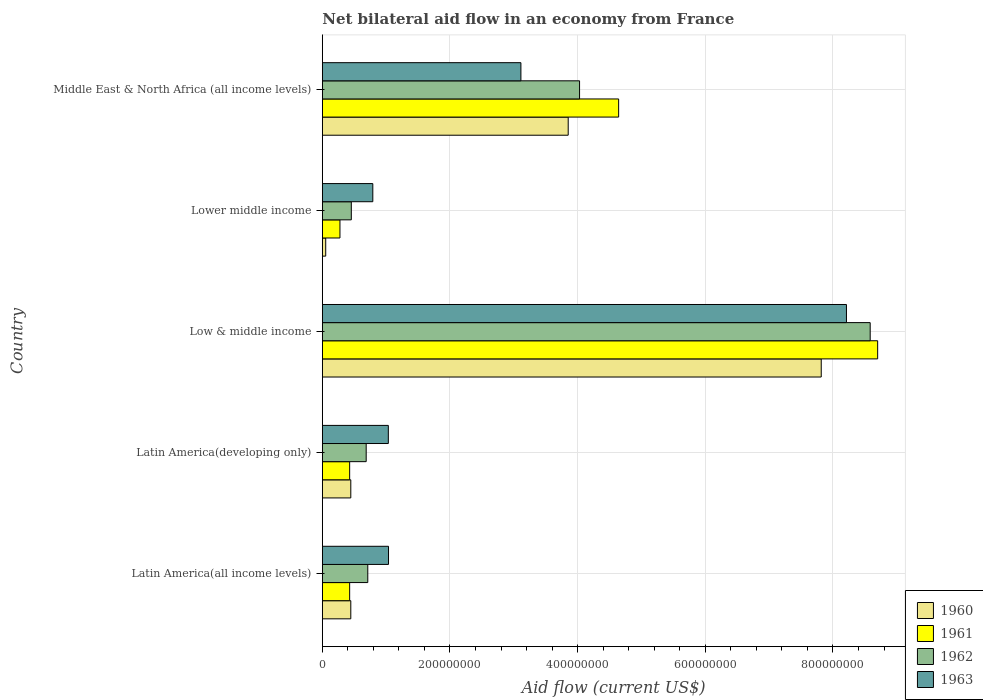How many different coloured bars are there?
Keep it short and to the point. 4. How many bars are there on the 4th tick from the bottom?
Provide a short and direct response. 4. What is the label of the 5th group of bars from the top?
Provide a succinct answer. Latin America(all income levels). What is the net bilateral aid flow in 1960 in Latin America(all income levels)?
Your response must be concise. 4.46e+07. Across all countries, what is the maximum net bilateral aid flow in 1963?
Ensure brevity in your answer.  8.21e+08. Across all countries, what is the minimum net bilateral aid flow in 1963?
Ensure brevity in your answer.  7.91e+07. In which country was the net bilateral aid flow in 1961 minimum?
Make the answer very short. Lower middle income. What is the total net bilateral aid flow in 1961 in the graph?
Ensure brevity in your answer.  1.45e+09. What is the difference between the net bilateral aid flow in 1962 in Low & middle income and that in Lower middle income?
Offer a terse response. 8.13e+08. What is the difference between the net bilateral aid flow in 1961 in Latin America(developing only) and the net bilateral aid flow in 1960 in Low & middle income?
Offer a terse response. -7.39e+08. What is the average net bilateral aid flow in 1963 per country?
Offer a very short reply. 2.84e+08. What is the difference between the net bilateral aid flow in 1960 and net bilateral aid flow in 1962 in Middle East & North Africa (all income levels)?
Provide a short and direct response. -1.78e+07. What is the ratio of the net bilateral aid flow in 1960 in Lower middle income to that in Middle East & North Africa (all income levels)?
Give a very brief answer. 0.01. Is the difference between the net bilateral aid flow in 1960 in Latin America(all income levels) and Low & middle income greater than the difference between the net bilateral aid flow in 1962 in Latin America(all income levels) and Low & middle income?
Provide a succinct answer. Yes. What is the difference between the highest and the second highest net bilateral aid flow in 1961?
Ensure brevity in your answer.  4.06e+08. What is the difference between the highest and the lowest net bilateral aid flow in 1961?
Make the answer very short. 8.42e+08. Is the sum of the net bilateral aid flow in 1963 in Latin America(all income levels) and Low & middle income greater than the maximum net bilateral aid flow in 1961 across all countries?
Provide a short and direct response. Yes. Is it the case that in every country, the sum of the net bilateral aid flow in 1961 and net bilateral aid flow in 1963 is greater than the sum of net bilateral aid flow in 1962 and net bilateral aid flow in 1960?
Ensure brevity in your answer.  No. What does the 1st bar from the top in Latin America(all income levels) represents?
Your response must be concise. 1963. Is it the case that in every country, the sum of the net bilateral aid flow in 1962 and net bilateral aid flow in 1961 is greater than the net bilateral aid flow in 1960?
Provide a short and direct response. Yes. How many countries are there in the graph?
Your answer should be very brief. 5. How many legend labels are there?
Ensure brevity in your answer.  4. How are the legend labels stacked?
Your answer should be compact. Vertical. What is the title of the graph?
Keep it short and to the point. Net bilateral aid flow in an economy from France. What is the label or title of the X-axis?
Your answer should be compact. Aid flow (current US$). What is the label or title of the Y-axis?
Provide a succinct answer. Country. What is the Aid flow (current US$) in 1960 in Latin America(all income levels)?
Offer a very short reply. 4.46e+07. What is the Aid flow (current US$) of 1961 in Latin America(all income levels)?
Give a very brief answer. 4.28e+07. What is the Aid flow (current US$) in 1962 in Latin America(all income levels)?
Make the answer very short. 7.12e+07. What is the Aid flow (current US$) of 1963 in Latin America(all income levels)?
Offer a terse response. 1.04e+08. What is the Aid flow (current US$) in 1960 in Latin America(developing only)?
Ensure brevity in your answer.  4.46e+07. What is the Aid flow (current US$) of 1961 in Latin America(developing only)?
Your answer should be compact. 4.28e+07. What is the Aid flow (current US$) of 1962 in Latin America(developing only)?
Provide a succinct answer. 6.87e+07. What is the Aid flow (current US$) of 1963 in Latin America(developing only)?
Provide a succinct answer. 1.03e+08. What is the Aid flow (current US$) of 1960 in Low & middle income?
Offer a very short reply. 7.82e+08. What is the Aid flow (current US$) of 1961 in Low & middle income?
Your answer should be very brief. 8.70e+08. What is the Aid flow (current US$) of 1962 in Low & middle income?
Offer a very short reply. 8.58e+08. What is the Aid flow (current US$) of 1963 in Low & middle income?
Keep it short and to the point. 8.21e+08. What is the Aid flow (current US$) in 1960 in Lower middle income?
Provide a succinct answer. 5.30e+06. What is the Aid flow (current US$) of 1961 in Lower middle income?
Keep it short and to the point. 2.76e+07. What is the Aid flow (current US$) in 1962 in Lower middle income?
Make the answer very short. 4.54e+07. What is the Aid flow (current US$) of 1963 in Lower middle income?
Provide a succinct answer. 7.91e+07. What is the Aid flow (current US$) of 1960 in Middle East & North Africa (all income levels)?
Provide a succinct answer. 3.85e+08. What is the Aid flow (current US$) of 1961 in Middle East & North Africa (all income levels)?
Keep it short and to the point. 4.64e+08. What is the Aid flow (current US$) in 1962 in Middle East & North Africa (all income levels)?
Give a very brief answer. 4.03e+08. What is the Aid flow (current US$) in 1963 in Middle East & North Africa (all income levels)?
Your answer should be compact. 3.11e+08. Across all countries, what is the maximum Aid flow (current US$) of 1960?
Provide a succinct answer. 7.82e+08. Across all countries, what is the maximum Aid flow (current US$) of 1961?
Provide a succinct answer. 8.70e+08. Across all countries, what is the maximum Aid flow (current US$) in 1962?
Your answer should be compact. 8.58e+08. Across all countries, what is the maximum Aid flow (current US$) of 1963?
Keep it short and to the point. 8.21e+08. Across all countries, what is the minimum Aid flow (current US$) of 1960?
Ensure brevity in your answer.  5.30e+06. Across all countries, what is the minimum Aid flow (current US$) of 1961?
Provide a short and direct response. 2.76e+07. Across all countries, what is the minimum Aid flow (current US$) of 1962?
Your answer should be very brief. 4.54e+07. Across all countries, what is the minimum Aid flow (current US$) in 1963?
Give a very brief answer. 7.91e+07. What is the total Aid flow (current US$) of 1960 in the graph?
Give a very brief answer. 1.26e+09. What is the total Aid flow (current US$) of 1961 in the graph?
Offer a very short reply. 1.45e+09. What is the total Aid flow (current US$) in 1962 in the graph?
Provide a short and direct response. 1.45e+09. What is the total Aid flow (current US$) in 1963 in the graph?
Keep it short and to the point. 1.42e+09. What is the difference between the Aid flow (current US$) of 1962 in Latin America(all income levels) and that in Latin America(developing only)?
Your answer should be very brief. 2.50e+06. What is the difference between the Aid flow (current US$) of 1963 in Latin America(all income levels) and that in Latin America(developing only)?
Your response must be concise. 3.00e+05. What is the difference between the Aid flow (current US$) in 1960 in Latin America(all income levels) and that in Low & middle income?
Make the answer very short. -7.37e+08. What is the difference between the Aid flow (current US$) of 1961 in Latin America(all income levels) and that in Low & middle income?
Provide a short and direct response. -8.27e+08. What is the difference between the Aid flow (current US$) in 1962 in Latin America(all income levels) and that in Low & middle income?
Your answer should be compact. -7.87e+08. What is the difference between the Aid flow (current US$) of 1963 in Latin America(all income levels) and that in Low & middle income?
Keep it short and to the point. -7.17e+08. What is the difference between the Aid flow (current US$) of 1960 in Latin America(all income levels) and that in Lower middle income?
Your answer should be compact. 3.93e+07. What is the difference between the Aid flow (current US$) in 1961 in Latin America(all income levels) and that in Lower middle income?
Offer a very short reply. 1.52e+07. What is the difference between the Aid flow (current US$) in 1962 in Latin America(all income levels) and that in Lower middle income?
Your answer should be compact. 2.58e+07. What is the difference between the Aid flow (current US$) of 1963 in Latin America(all income levels) and that in Lower middle income?
Give a very brief answer. 2.46e+07. What is the difference between the Aid flow (current US$) of 1960 in Latin America(all income levels) and that in Middle East & North Africa (all income levels)?
Your answer should be compact. -3.41e+08. What is the difference between the Aid flow (current US$) of 1961 in Latin America(all income levels) and that in Middle East & North Africa (all income levels)?
Give a very brief answer. -4.21e+08. What is the difference between the Aid flow (current US$) in 1962 in Latin America(all income levels) and that in Middle East & North Africa (all income levels)?
Offer a very short reply. -3.32e+08. What is the difference between the Aid flow (current US$) in 1963 in Latin America(all income levels) and that in Middle East & North Africa (all income levels)?
Your response must be concise. -2.07e+08. What is the difference between the Aid flow (current US$) of 1960 in Latin America(developing only) and that in Low & middle income?
Ensure brevity in your answer.  -7.37e+08. What is the difference between the Aid flow (current US$) in 1961 in Latin America(developing only) and that in Low & middle income?
Provide a short and direct response. -8.27e+08. What is the difference between the Aid flow (current US$) in 1962 in Latin America(developing only) and that in Low & middle income?
Ensure brevity in your answer.  -7.90e+08. What is the difference between the Aid flow (current US$) in 1963 in Latin America(developing only) and that in Low & middle income?
Offer a very short reply. -7.18e+08. What is the difference between the Aid flow (current US$) of 1960 in Latin America(developing only) and that in Lower middle income?
Provide a succinct answer. 3.93e+07. What is the difference between the Aid flow (current US$) in 1961 in Latin America(developing only) and that in Lower middle income?
Give a very brief answer. 1.52e+07. What is the difference between the Aid flow (current US$) in 1962 in Latin America(developing only) and that in Lower middle income?
Your answer should be compact. 2.33e+07. What is the difference between the Aid flow (current US$) in 1963 in Latin America(developing only) and that in Lower middle income?
Ensure brevity in your answer.  2.43e+07. What is the difference between the Aid flow (current US$) of 1960 in Latin America(developing only) and that in Middle East & North Africa (all income levels)?
Give a very brief answer. -3.41e+08. What is the difference between the Aid flow (current US$) in 1961 in Latin America(developing only) and that in Middle East & North Africa (all income levels)?
Your response must be concise. -4.21e+08. What is the difference between the Aid flow (current US$) of 1962 in Latin America(developing only) and that in Middle East & North Africa (all income levels)?
Offer a very short reply. -3.34e+08. What is the difference between the Aid flow (current US$) in 1963 in Latin America(developing only) and that in Middle East & North Africa (all income levels)?
Keep it short and to the point. -2.08e+08. What is the difference between the Aid flow (current US$) of 1960 in Low & middle income and that in Lower middle income?
Your answer should be very brief. 7.76e+08. What is the difference between the Aid flow (current US$) in 1961 in Low & middle income and that in Lower middle income?
Keep it short and to the point. 8.42e+08. What is the difference between the Aid flow (current US$) of 1962 in Low & middle income and that in Lower middle income?
Provide a short and direct response. 8.13e+08. What is the difference between the Aid flow (current US$) of 1963 in Low & middle income and that in Lower middle income?
Keep it short and to the point. 7.42e+08. What is the difference between the Aid flow (current US$) of 1960 in Low & middle income and that in Middle East & North Africa (all income levels)?
Your answer should be compact. 3.96e+08. What is the difference between the Aid flow (current US$) of 1961 in Low & middle income and that in Middle East & North Africa (all income levels)?
Make the answer very short. 4.06e+08. What is the difference between the Aid flow (current US$) in 1962 in Low & middle income and that in Middle East & North Africa (all income levels)?
Keep it short and to the point. 4.55e+08. What is the difference between the Aid flow (current US$) of 1963 in Low & middle income and that in Middle East & North Africa (all income levels)?
Give a very brief answer. 5.10e+08. What is the difference between the Aid flow (current US$) of 1960 in Lower middle income and that in Middle East & North Africa (all income levels)?
Provide a succinct answer. -3.80e+08. What is the difference between the Aid flow (current US$) in 1961 in Lower middle income and that in Middle East & North Africa (all income levels)?
Keep it short and to the point. -4.37e+08. What is the difference between the Aid flow (current US$) in 1962 in Lower middle income and that in Middle East & North Africa (all income levels)?
Your answer should be very brief. -3.58e+08. What is the difference between the Aid flow (current US$) of 1963 in Lower middle income and that in Middle East & North Africa (all income levels)?
Your response must be concise. -2.32e+08. What is the difference between the Aid flow (current US$) in 1960 in Latin America(all income levels) and the Aid flow (current US$) in 1961 in Latin America(developing only)?
Keep it short and to the point. 1.80e+06. What is the difference between the Aid flow (current US$) in 1960 in Latin America(all income levels) and the Aid flow (current US$) in 1962 in Latin America(developing only)?
Your answer should be compact. -2.41e+07. What is the difference between the Aid flow (current US$) in 1960 in Latin America(all income levels) and the Aid flow (current US$) in 1963 in Latin America(developing only)?
Ensure brevity in your answer.  -5.88e+07. What is the difference between the Aid flow (current US$) of 1961 in Latin America(all income levels) and the Aid flow (current US$) of 1962 in Latin America(developing only)?
Offer a terse response. -2.59e+07. What is the difference between the Aid flow (current US$) in 1961 in Latin America(all income levels) and the Aid flow (current US$) in 1963 in Latin America(developing only)?
Ensure brevity in your answer.  -6.06e+07. What is the difference between the Aid flow (current US$) of 1962 in Latin America(all income levels) and the Aid flow (current US$) of 1963 in Latin America(developing only)?
Offer a terse response. -3.22e+07. What is the difference between the Aid flow (current US$) in 1960 in Latin America(all income levels) and the Aid flow (current US$) in 1961 in Low & middle income?
Ensure brevity in your answer.  -8.25e+08. What is the difference between the Aid flow (current US$) in 1960 in Latin America(all income levels) and the Aid flow (current US$) in 1962 in Low & middle income?
Your response must be concise. -8.14e+08. What is the difference between the Aid flow (current US$) in 1960 in Latin America(all income levels) and the Aid flow (current US$) in 1963 in Low & middle income?
Provide a short and direct response. -7.76e+08. What is the difference between the Aid flow (current US$) in 1961 in Latin America(all income levels) and the Aid flow (current US$) in 1962 in Low & middle income?
Your answer should be compact. -8.16e+08. What is the difference between the Aid flow (current US$) of 1961 in Latin America(all income levels) and the Aid flow (current US$) of 1963 in Low & middle income?
Provide a succinct answer. -7.78e+08. What is the difference between the Aid flow (current US$) in 1962 in Latin America(all income levels) and the Aid flow (current US$) in 1963 in Low & middle income?
Ensure brevity in your answer.  -7.50e+08. What is the difference between the Aid flow (current US$) of 1960 in Latin America(all income levels) and the Aid flow (current US$) of 1961 in Lower middle income?
Keep it short and to the point. 1.70e+07. What is the difference between the Aid flow (current US$) in 1960 in Latin America(all income levels) and the Aid flow (current US$) in 1962 in Lower middle income?
Keep it short and to the point. -8.00e+05. What is the difference between the Aid flow (current US$) of 1960 in Latin America(all income levels) and the Aid flow (current US$) of 1963 in Lower middle income?
Make the answer very short. -3.45e+07. What is the difference between the Aid flow (current US$) in 1961 in Latin America(all income levels) and the Aid flow (current US$) in 1962 in Lower middle income?
Offer a very short reply. -2.60e+06. What is the difference between the Aid flow (current US$) in 1961 in Latin America(all income levels) and the Aid flow (current US$) in 1963 in Lower middle income?
Give a very brief answer. -3.63e+07. What is the difference between the Aid flow (current US$) of 1962 in Latin America(all income levels) and the Aid flow (current US$) of 1963 in Lower middle income?
Make the answer very short. -7.90e+06. What is the difference between the Aid flow (current US$) in 1960 in Latin America(all income levels) and the Aid flow (current US$) in 1961 in Middle East & North Africa (all income levels)?
Ensure brevity in your answer.  -4.20e+08. What is the difference between the Aid flow (current US$) in 1960 in Latin America(all income levels) and the Aid flow (current US$) in 1962 in Middle East & North Africa (all income levels)?
Provide a short and direct response. -3.58e+08. What is the difference between the Aid flow (current US$) in 1960 in Latin America(all income levels) and the Aid flow (current US$) in 1963 in Middle East & North Africa (all income levels)?
Offer a terse response. -2.66e+08. What is the difference between the Aid flow (current US$) in 1961 in Latin America(all income levels) and the Aid flow (current US$) in 1962 in Middle East & North Africa (all income levels)?
Provide a succinct answer. -3.60e+08. What is the difference between the Aid flow (current US$) of 1961 in Latin America(all income levels) and the Aid flow (current US$) of 1963 in Middle East & North Africa (all income levels)?
Offer a very short reply. -2.68e+08. What is the difference between the Aid flow (current US$) in 1962 in Latin America(all income levels) and the Aid flow (current US$) in 1963 in Middle East & North Africa (all income levels)?
Your answer should be very brief. -2.40e+08. What is the difference between the Aid flow (current US$) of 1960 in Latin America(developing only) and the Aid flow (current US$) of 1961 in Low & middle income?
Provide a short and direct response. -8.25e+08. What is the difference between the Aid flow (current US$) in 1960 in Latin America(developing only) and the Aid flow (current US$) in 1962 in Low & middle income?
Your response must be concise. -8.14e+08. What is the difference between the Aid flow (current US$) in 1960 in Latin America(developing only) and the Aid flow (current US$) in 1963 in Low & middle income?
Your response must be concise. -7.76e+08. What is the difference between the Aid flow (current US$) in 1961 in Latin America(developing only) and the Aid flow (current US$) in 1962 in Low & middle income?
Keep it short and to the point. -8.16e+08. What is the difference between the Aid flow (current US$) of 1961 in Latin America(developing only) and the Aid flow (current US$) of 1963 in Low & middle income?
Keep it short and to the point. -7.78e+08. What is the difference between the Aid flow (current US$) in 1962 in Latin America(developing only) and the Aid flow (current US$) in 1963 in Low & middle income?
Offer a very short reply. -7.52e+08. What is the difference between the Aid flow (current US$) in 1960 in Latin America(developing only) and the Aid flow (current US$) in 1961 in Lower middle income?
Offer a very short reply. 1.70e+07. What is the difference between the Aid flow (current US$) of 1960 in Latin America(developing only) and the Aid flow (current US$) of 1962 in Lower middle income?
Ensure brevity in your answer.  -8.00e+05. What is the difference between the Aid flow (current US$) in 1960 in Latin America(developing only) and the Aid flow (current US$) in 1963 in Lower middle income?
Your response must be concise. -3.45e+07. What is the difference between the Aid flow (current US$) in 1961 in Latin America(developing only) and the Aid flow (current US$) in 1962 in Lower middle income?
Your response must be concise. -2.60e+06. What is the difference between the Aid flow (current US$) in 1961 in Latin America(developing only) and the Aid flow (current US$) in 1963 in Lower middle income?
Your response must be concise. -3.63e+07. What is the difference between the Aid flow (current US$) in 1962 in Latin America(developing only) and the Aid flow (current US$) in 1963 in Lower middle income?
Offer a terse response. -1.04e+07. What is the difference between the Aid flow (current US$) in 1960 in Latin America(developing only) and the Aid flow (current US$) in 1961 in Middle East & North Africa (all income levels)?
Make the answer very short. -4.20e+08. What is the difference between the Aid flow (current US$) of 1960 in Latin America(developing only) and the Aid flow (current US$) of 1962 in Middle East & North Africa (all income levels)?
Keep it short and to the point. -3.58e+08. What is the difference between the Aid flow (current US$) in 1960 in Latin America(developing only) and the Aid flow (current US$) in 1963 in Middle East & North Africa (all income levels)?
Give a very brief answer. -2.66e+08. What is the difference between the Aid flow (current US$) in 1961 in Latin America(developing only) and the Aid flow (current US$) in 1962 in Middle East & North Africa (all income levels)?
Your answer should be very brief. -3.60e+08. What is the difference between the Aid flow (current US$) of 1961 in Latin America(developing only) and the Aid flow (current US$) of 1963 in Middle East & North Africa (all income levels)?
Your answer should be very brief. -2.68e+08. What is the difference between the Aid flow (current US$) of 1962 in Latin America(developing only) and the Aid flow (current US$) of 1963 in Middle East & North Africa (all income levels)?
Your answer should be compact. -2.42e+08. What is the difference between the Aid flow (current US$) of 1960 in Low & middle income and the Aid flow (current US$) of 1961 in Lower middle income?
Your answer should be compact. 7.54e+08. What is the difference between the Aid flow (current US$) of 1960 in Low & middle income and the Aid flow (current US$) of 1962 in Lower middle income?
Ensure brevity in your answer.  7.36e+08. What is the difference between the Aid flow (current US$) of 1960 in Low & middle income and the Aid flow (current US$) of 1963 in Lower middle income?
Your response must be concise. 7.02e+08. What is the difference between the Aid flow (current US$) in 1961 in Low & middle income and the Aid flow (current US$) in 1962 in Lower middle income?
Offer a terse response. 8.25e+08. What is the difference between the Aid flow (current US$) in 1961 in Low & middle income and the Aid flow (current US$) in 1963 in Lower middle income?
Provide a short and direct response. 7.91e+08. What is the difference between the Aid flow (current US$) of 1962 in Low & middle income and the Aid flow (current US$) of 1963 in Lower middle income?
Your answer should be very brief. 7.79e+08. What is the difference between the Aid flow (current US$) of 1960 in Low & middle income and the Aid flow (current US$) of 1961 in Middle East & North Africa (all income levels)?
Keep it short and to the point. 3.17e+08. What is the difference between the Aid flow (current US$) in 1960 in Low & middle income and the Aid flow (current US$) in 1962 in Middle East & North Africa (all income levels)?
Keep it short and to the point. 3.79e+08. What is the difference between the Aid flow (current US$) in 1960 in Low & middle income and the Aid flow (current US$) in 1963 in Middle East & North Africa (all income levels)?
Provide a short and direct response. 4.70e+08. What is the difference between the Aid flow (current US$) in 1961 in Low & middle income and the Aid flow (current US$) in 1962 in Middle East & North Africa (all income levels)?
Offer a terse response. 4.67e+08. What is the difference between the Aid flow (current US$) in 1961 in Low & middle income and the Aid flow (current US$) in 1963 in Middle East & North Africa (all income levels)?
Keep it short and to the point. 5.59e+08. What is the difference between the Aid flow (current US$) in 1962 in Low & middle income and the Aid flow (current US$) in 1963 in Middle East & North Africa (all income levels)?
Your answer should be compact. 5.47e+08. What is the difference between the Aid flow (current US$) in 1960 in Lower middle income and the Aid flow (current US$) in 1961 in Middle East & North Africa (all income levels)?
Provide a succinct answer. -4.59e+08. What is the difference between the Aid flow (current US$) in 1960 in Lower middle income and the Aid flow (current US$) in 1962 in Middle East & North Africa (all income levels)?
Your response must be concise. -3.98e+08. What is the difference between the Aid flow (current US$) of 1960 in Lower middle income and the Aid flow (current US$) of 1963 in Middle East & North Africa (all income levels)?
Give a very brief answer. -3.06e+08. What is the difference between the Aid flow (current US$) in 1961 in Lower middle income and the Aid flow (current US$) in 1962 in Middle East & North Africa (all income levels)?
Your response must be concise. -3.75e+08. What is the difference between the Aid flow (current US$) in 1961 in Lower middle income and the Aid flow (current US$) in 1963 in Middle East & North Africa (all income levels)?
Offer a very short reply. -2.84e+08. What is the difference between the Aid flow (current US$) of 1962 in Lower middle income and the Aid flow (current US$) of 1963 in Middle East & North Africa (all income levels)?
Provide a succinct answer. -2.66e+08. What is the average Aid flow (current US$) of 1960 per country?
Ensure brevity in your answer.  2.52e+08. What is the average Aid flow (current US$) in 1961 per country?
Provide a short and direct response. 2.89e+08. What is the average Aid flow (current US$) in 1962 per country?
Make the answer very short. 2.89e+08. What is the average Aid flow (current US$) in 1963 per country?
Your response must be concise. 2.84e+08. What is the difference between the Aid flow (current US$) of 1960 and Aid flow (current US$) of 1961 in Latin America(all income levels)?
Your answer should be compact. 1.80e+06. What is the difference between the Aid flow (current US$) of 1960 and Aid flow (current US$) of 1962 in Latin America(all income levels)?
Make the answer very short. -2.66e+07. What is the difference between the Aid flow (current US$) of 1960 and Aid flow (current US$) of 1963 in Latin America(all income levels)?
Keep it short and to the point. -5.91e+07. What is the difference between the Aid flow (current US$) of 1961 and Aid flow (current US$) of 1962 in Latin America(all income levels)?
Make the answer very short. -2.84e+07. What is the difference between the Aid flow (current US$) of 1961 and Aid flow (current US$) of 1963 in Latin America(all income levels)?
Your response must be concise. -6.09e+07. What is the difference between the Aid flow (current US$) in 1962 and Aid flow (current US$) in 1963 in Latin America(all income levels)?
Offer a terse response. -3.25e+07. What is the difference between the Aid flow (current US$) in 1960 and Aid flow (current US$) in 1961 in Latin America(developing only)?
Offer a very short reply. 1.80e+06. What is the difference between the Aid flow (current US$) in 1960 and Aid flow (current US$) in 1962 in Latin America(developing only)?
Give a very brief answer. -2.41e+07. What is the difference between the Aid flow (current US$) in 1960 and Aid flow (current US$) in 1963 in Latin America(developing only)?
Give a very brief answer. -5.88e+07. What is the difference between the Aid flow (current US$) in 1961 and Aid flow (current US$) in 1962 in Latin America(developing only)?
Ensure brevity in your answer.  -2.59e+07. What is the difference between the Aid flow (current US$) of 1961 and Aid flow (current US$) of 1963 in Latin America(developing only)?
Offer a terse response. -6.06e+07. What is the difference between the Aid flow (current US$) in 1962 and Aid flow (current US$) in 1963 in Latin America(developing only)?
Ensure brevity in your answer.  -3.47e+07. What is the difference between the Aid flow (current US$) in 1960 and Aid flow (current US$) in 1961 in Low & middle income?
Your answer should be very brief. -8.84e+07. What is the difference between the Aid flow (current US$) of 1960 and Aid flow (current US$) of 1962 in Low & middle income?
Your answer should be compact. -7.67e+07. What is the difference between the Aid flow (current US$) in 1960 and Aid flow (current US$) in 1963 in Low & middle income?
Your response must be concise. -3.95e+07. What is the difference between the Aid flow (current US$) of 1961 and Aid flow (current US$) of 1962 in Low & middle income?
Make the answer very short. 1.17e+07. What is the difference between the Aid flow (current US$) in 1961 and Aid flow (current US$) in 1963 in Low & middle income?
Offer a terse response. 4.89e+07. What is the difference between the Aid flow (current US$) in 1962 and Aid flow (current US$) in 1963 in Low & middle income?
Keep it short and to the point. 3.72e+07. What is the difference between the Aid flow (current US$) in 1960 and Aid flow (current US$) in 1961 in Lower middle income?
Your response must be concise. -2.23e+07. What is the difference between the Aid flow (current US$) of 1960 and Aid flow (current US$) of 1962 in Lower middle income?
Your answer should be very brief. -4.01e+07. What is the difference between the Aid flow (current US$) of 1960 and Aid flow (current US$) of 1963 in Lower middle income?
Your response must be concise. -7.38e+07. What is the difference between the Aid flow (current US$) of 1961 and Aid flow (current US$) of 1962 in Lower middle income?
Your answer should be very brief. -1.78e+07. What is the difference between the Aid flow (current US$) in 1961 and Aid flow (current US$) in 1963 in Lower middle income?
Make the answer very short. -5.15e+07. What is the difference between the Aid flow (current US$) of 1962 and Aid flow (current US$) of 1963 in Lower middle income?
Make the answer very short. -3.37e+07. What is the difference between the Aid flow (current US$) of 1960 and Aid flow (current US$) of 1961 in Middle East & North Africa (all income levels)?
Your answer should be compact. -7.90e+07. What is the difference between the Aid flow (current US$) of 1960 and Aid flow (current US$) of 1962 in Middle East & North Africa (all income levels)?
Ensure brevity in your answer.  -1.78e+07. What is the difference between the Aid flow (current US$) of 1960 and Aid flow (current US$) of 1963 in Middle East & North Africa (all income levels)?
Offer a very short reply. 7.41e+07. What is the difference between the Aid flow (current US$) in 1961 and Aid flow (current US$) in 1962 in Middle East & North Africa (all income levels)?
Provide a short and direct response. 6.12e+07. What is the difference between the Aid flow (current US$) in 1961 and Aid flow (current US$) in 1963 in Middle East & North Africa (all income levels)?
Your response must be concise. 1.53e+08. What is the difference between the Aid flow (current US$) of 1962 and Aid flow (current US$) of 1963 in Middle East & North Africa (all income levels)?
Your response must be concise. 9.19e+07. What is the ratio of the Aid flow (current US$) of 1960 in Latin America(all income levels) to that in Latin America(developing only)?
Your answer should be very brief. 1. What is the ratio of the Aid flow (current US$) of 1961 in Latin America(all income levels) to that in Latin America(developing only)?
Offer a terse response. 1. What is the ratio of the Aid flow (current US$) of 1962 in Latin America(all income levels) to that in Latin America(developing only)?
Keep it short and to the point. 1.04. What is the ratio of the Aid flow (current US$) of 1963 in Latin America(all income levels) to that in Latin America(developing only)?
Offer a terse response. 1. What is the ratio of the Aid flow (current US$) of 1960 in Latin America(all income levels) to that in Low & middle income?
Provide a short and direct response. 0.06. What is the ratio of the Aid flow (current US$) in 1961 in Latin America(all income levels) to that in Low & middle income?
Provide a short and direct response. 0.05. What is the ratio of the Aid flow (current US$) of 1962 in Latin America(all income levels) to that in Low & middle income?
Your answer should be very brief. 0.08. What is the ratio of the Aid flow (current US$) in 1963 in Latin America(all income levels) to that in Low & middle income?
Give a very brief answer. 0.13. What is the ratio of the Aid flow (current US$) in 1960 in Latin America(all income levels) to that in Lower middle income?
Offer a terse response. 8.42. What is the ratio of the Aid flow (current US$) in 1961 in Latin America(all income levels) to that in Lower middle income?
Offer a very short reply. 1.55. What is the ratio of the Aid flow (current US$) in 1962 in Latin America(all income levels) to that in Lower middle income?
Provide a short and direct response. 1.57. What is the ratio of the Aid flow (current US$) in 1963 in Latin America(all income levels) to that in Lower middle income?
Give a very brief answer. 1.31. What is the ratio of the Aid flow (current US$) in 1960 in Latin America(all income levels) to that in Middle East & North Africa (all income levels)?
Provide a short and direct response. 0.12. What is the ratio of the Aid flow (current US$) of 1961 in Latin America(all income levels) to that in Middle East & North Africa (all income levels)?
Provide a short and direct response. 0.09. What is the ratio of the Aid flow (current US$) in 1962 in Latin America(all income levels) to that in Middle East & North Africa (all income levels)?
Offer a very short reply. 0.18. What is the ratio of the Aid flow (current US$) of 1960 in Latin America(developing only) to that in Low & middle income?
Your answer should be very brief. 0.06. What is the ratio of the Aid flow (current US$) of 1961 in Latin America(developing only) to that in Low & middle income?
Your response must be concise. 0.05. What is the ratio of the Aid flow (current US$) of 1962 in Latin America(developing only) to that in Low & middle income?
Give a very brief answer. 0.08. What is the ratio of the Aid flow (current US$) in 1963 in Latin America(developing only) to that in Low & middle income?
Your response must be concise. 0.13. What is the ratio of the Aid flow (current US$) of 1960 in Latin America(developing only) to that in Lower middle income?
Ensure brevity in your answer.  8.42. What is the ratio of the Aid flow (current US$) in 1961 in Latin America(developing only) to that in Lower middle income?
Ensure brevity in your answer.  1.55. What is the ratio of the Aid flow (current US$) in 1962 in Latin America(developing only) to that in Lower middle income?
Give a very brief answer. 1.51. What is the ratio of the Aid flow (current US$) in 1963 in Latin America(developing only) to that in Lower middle income?
Give a very brief answer. 1.31. What is the ratio of the Aid flow (current US$) of 1960 in Latin America(developing only) to that in Middle East & North Africa (all income levels)?
Provide a succinct answer. 0.12. What is the ratio of the Aid flow (current US$) in 1961 in Latin America(developing only) to that in Middle East & North Africa (all income levels)?
Provide a short and direct response. 0.09. What is the ratio of the Aid flow (current US$) of 1962 in Latin America(developing only) to that in Middle East & North Africa (all income levels)?
Make the answer very short. 0.17. What is the ratio of the Aid flow (current US$) of 1963 in Latin America(developing only) to that in Middle East & North Africa (all income levels)?
Offer a terse response. 0.33. What is the ratio of the Aid flow (current US$) in 1960 in Low & middle income to that in Lower middle income?
Make the answer very short. 147.47. What is the ratio of the Aid flow (current US$) in 1961 in Low & middle income to that in Lower middle income?
Your response must be concise. 31.52. What is the ratio of the Aid flow (current US$) in 1962 in Low & middle income to that in Lower middle income?
Your answer should be very brief. 18.91. What is the ratio of the Aid flow (current US$) of 1963 in Low & middle income to that in Lower middle income?
Offer a terse response. 10.38. What is the ratio of the Aid flow (current US$) of 1960 in Low & middle income to that in Middle East & North Africa (all income levels)?
Keep it short and to the point. 2.03. What is the ratio of the Aid flow (current US$) of 1961 in Low & middle income to that in Middle East & North Africa (all income levels)?
Ensure brevity in your answer.  1.87. What is the ratio of the Aid flow (current US$) of 1962 in Low & middle income to that in Middle East & North Africa (all income levels)?
Keep it short and to the point. 2.13. What is the ratio of the Aid flow (current US$) of 1963 in Low & middle income to that in Middle East & North Africa (all income levels)?
Keep it short and to the point. 2.64. What is the ratio of the Aid flow (current US$) in 1960 in Lower middle income to that in Middle East & North Africa (all income levels)?
Give a very brief answer. 0.01. What is the ratio of the Aid flow (current US$) in 1961 in Lower middle income to that in Middle East & North Africa (all income levels)?
Your response must be concise. 0.06. What is the ratio of the Aid flow (current US$) in 1962 in Lower middle income to that in Middle East & North Africa (all income levels)?
Give a very brief answer. 0.11. What is the ratio of the Aid flow (current US$) in 1963 in Lower middle income to that in Middle East & North Africa (all income levels)?
Give a very brief answer. 0.25. What is the difference between the highest and the second highest Aid flow (current US$) in 1960?
Your answer should be very brief. 3.96e+08. What is the difference between the highest and the second highest Aid flow (current US$) in 1961?
Make the answer very short. 4.06e+08. What is the difference between the highest and the second highest Aid flow (current US$) of 1962?
Make the answer very short. 4.55e+08. What is the difference between the highest and the second highest Aid flow (current US$) in 1963?
Make the answer very short. 5.10e+08. What is the difference between the highest and the lowest Aid flow (current US$) of 1960?
Provide a succinct answer. 7.76e+08. What is the difference between the highest and the lowest Aid flow (current US$) in 1961?
Ensure brevity in your answer.  8.42e+08. What is the difference between the highest and the lowest Aid flow (current US$) of 1962?
Your answer should be compact. 8.13e+08. What is the difference between the highest and the lowest Aid flow (current US$) in 1963?
Ensure brevity in your answer.  7.42e+08. 